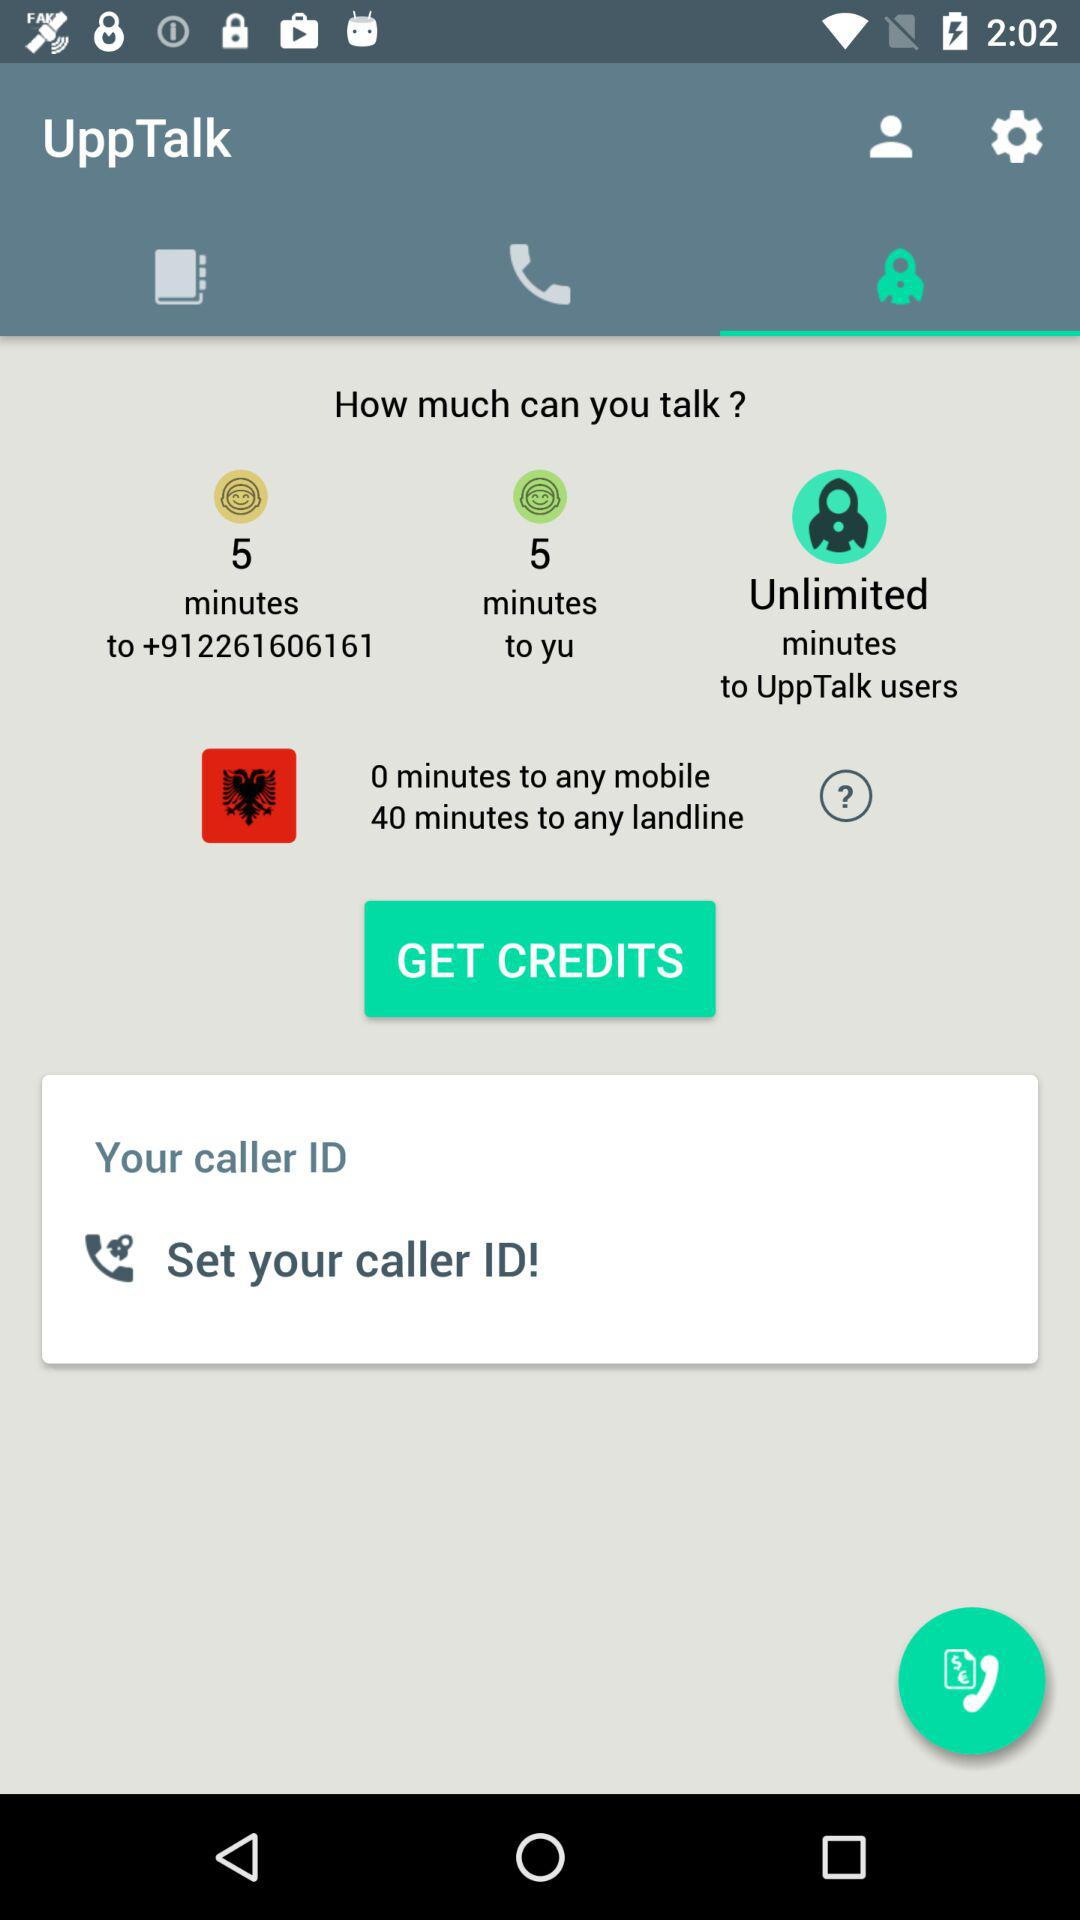How many more minutes are available to call landlines than mobiles?
Answer the question using a single word or phrase. 40 